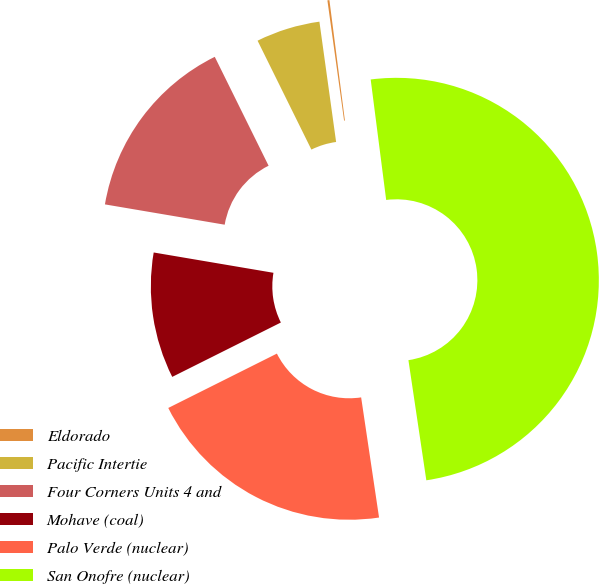Convert chart. <chart><loc_0><loc_0><loc_500><loc_500><pie_chart><fcel>Eldorado<fcel>Pacific Intertie<fcel>Four Corners Units 4 and<fcel>Mohave (coal)<fcel>Palo Verde (nuclear)<fcel>San Onofre (nuclear)<nl><fcel>0.16%<fcel>5.11%<fcel>15.02%<fcel>10.06%<fcel>19.97%<fcel>49.68%<nl></chart> 